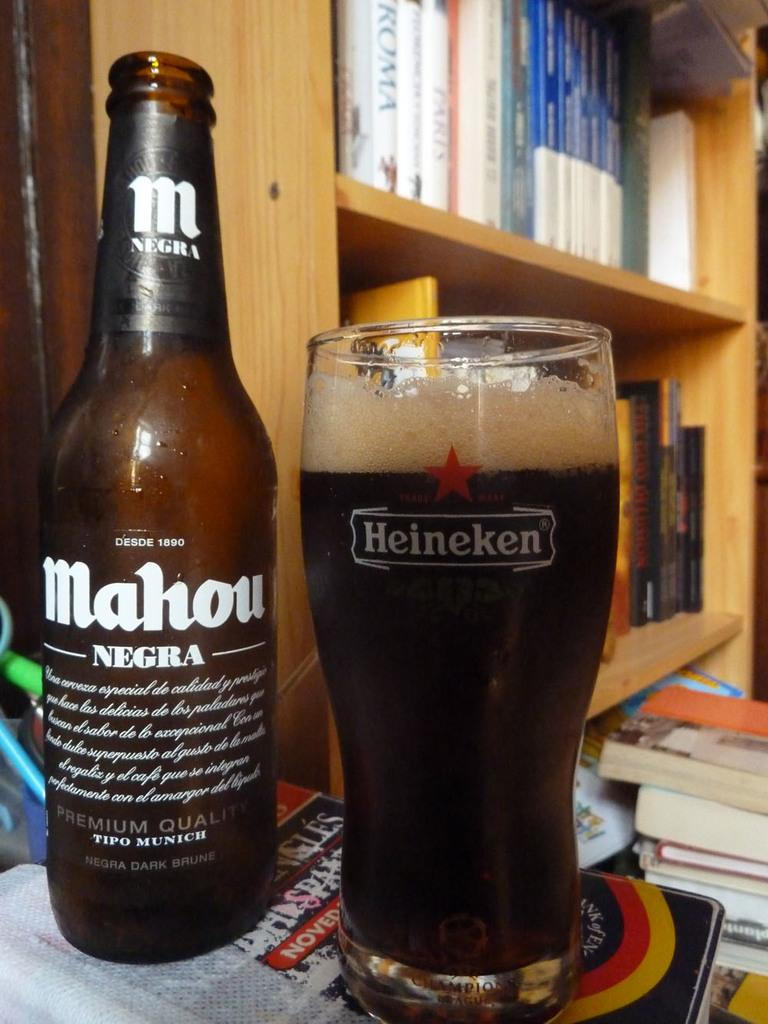What is on the table in the image? There is a bottle and a glass on the table in the image. What else can be seen in the image besides the table? There are books on a shelf in the image. What type of design can be seen on the curve of the glass in the image? There is no curve on the glass in the image, and therefore no design to observe. 